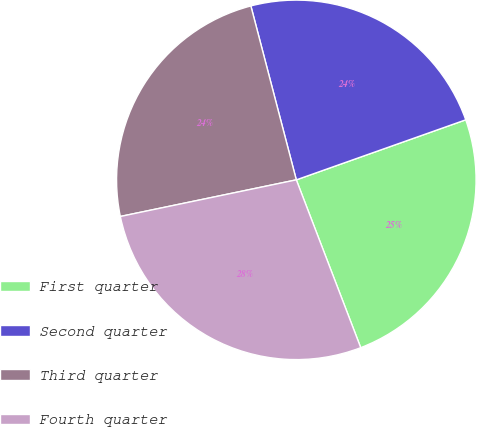Convert chart. <chart><loc_0><loc_0><loc_500><loc_500><pie_chart><fcel>First quarter<fcel>Second quarter<fcel>Third quarter<fcel>Fourth quarter<nl><fcel>24.59%<fcel>23.65%<fcel>24.2%<fcel>27.57%<nl></chart> 